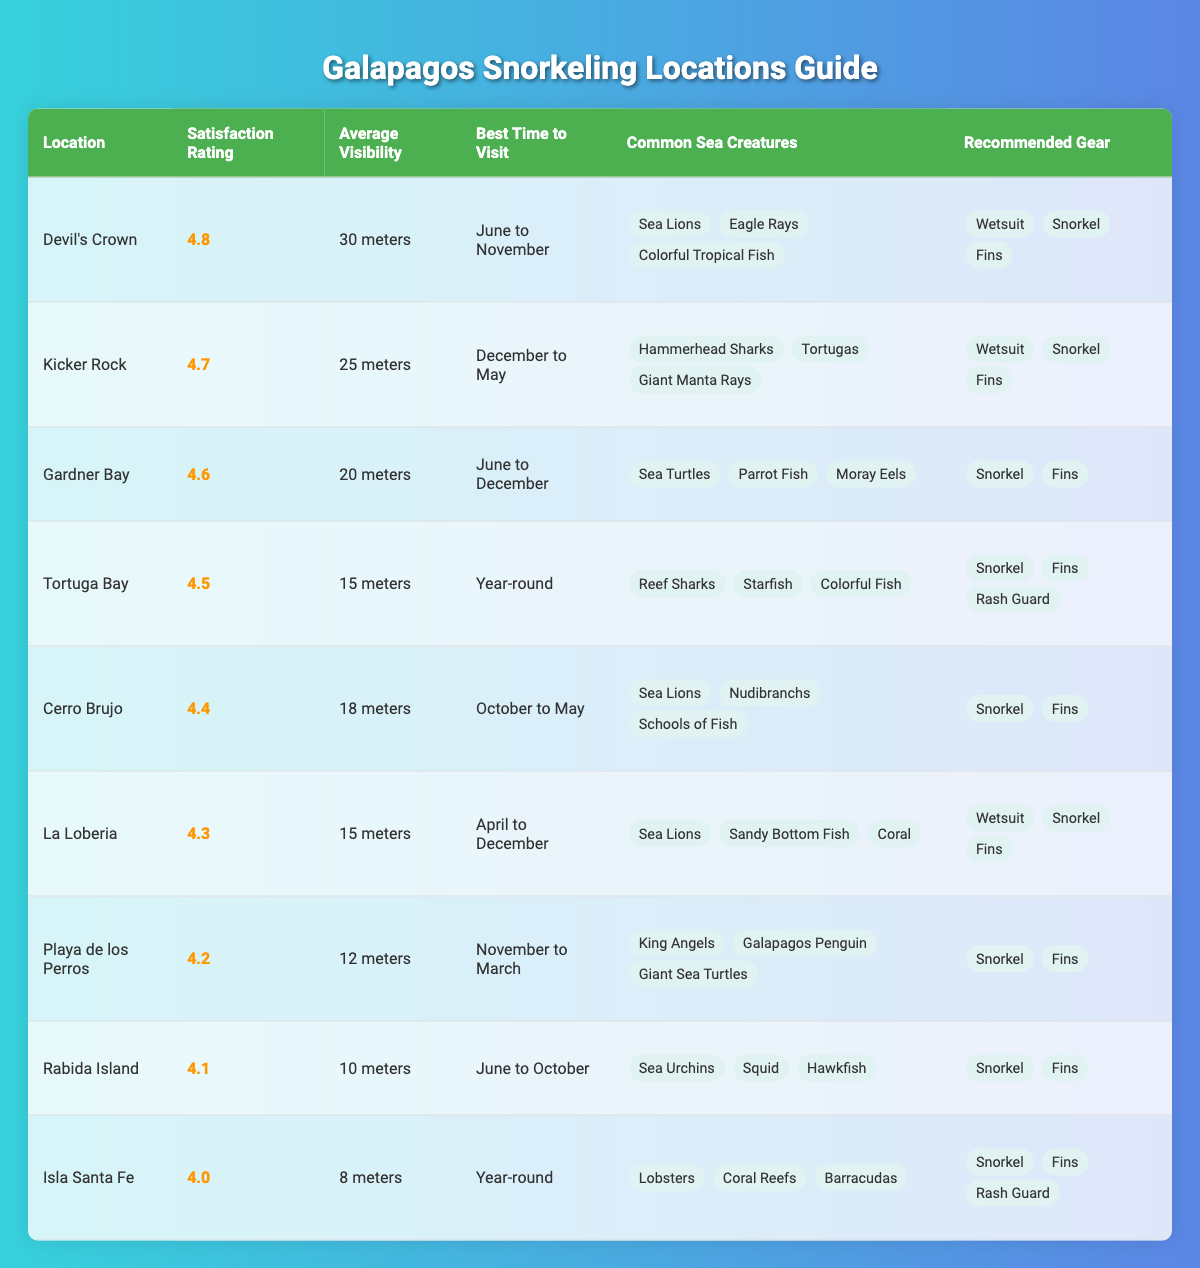What snorkeling location has the highest customer satisfaction rating? The table lists the customer satisfaction ratings for each location. By comparing the ratings, we see that Devil's Crown has the highest rating of 4.8.
Answer: Devil's Crown What is the average visibility at Kicker Rock? Kicker Rock has an average visibility of 25 meters according to the table, which directly indicates this value.
Answer: 25 meters How many snorkeling locations have a satisfaction rating of 4.5 or higher? By counting the locations with ratings of 4.5 or more (Devil's Crown, Kicker Rock, Gardner Bay, Tortuga Bay, Cerro Brujo, La Loberia, Playa de los Perros), we find a total of 7 locations.
Answer: 7 Is it true that Isla Santa Fe has a higher customer satisfaction rating than Rabida Island? According to the table, Isla Santa Fe has a rating of 4.0, while Rabida Island has a rating of 4.1. Therefore, it is false that Isla Santa Fe has a higher rating.
Answer: No Which snorkeling location has the least average visibility? The table indicates that Isla Santa Fe has the least average visibility at 8 meters among all listed locations.
Answer: Isla Santa Fe What is the difference in customer satisfaction ratings between Devil's Crown and La Loberia? Devil's Crown has a rating of 4.8 and La Loberia has a rating of 4.3. The difference is calculated as 4.8 - 4.3 = 0.5.
Answer: 0.5 Which location should be visited for the best chances to see Hammerhead Sharks? According to the common sea creatures listed, Kicker Rock is the only location where Hammerhead Sharks can be seen, as indicated in the table.
Answer: Kicker Rock What is the average customer satisfaction rating of locations that are best visited from June to November? The locations with this best time frame are Devil's Crown and Tortuga Bay. Their ratings are 4.8 and 4.5 respectively. The average is (4.8 + 4.5) / 2 = 4.65.
Answer: 4.65 Is the recommended gear for all locations the same? The table shows different recommended gear for various locations. For example, some locations suggest a wetsuit while others do not. Therefore, it's false that all have the same gear.
Answer: No Which snorkeling location is best visited year-round? The table specifies that Tortuga Bay and Isla Santa Fe can be visited year-round.
Answer: Tortuga Bay and Isla Santa Fe 